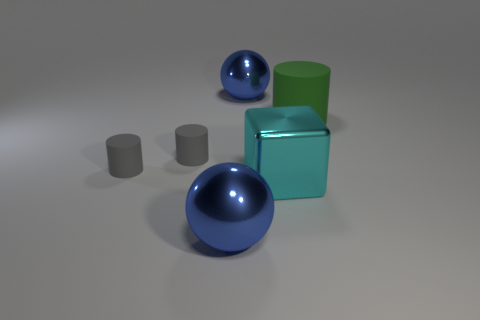Subtract all gray blocks. How many gray cylinders are left? 2 Subtract all tiny rubber cylinders. How many cylinders are left? 1 Add 1 large brown rubber spheres. How many objects exist? 7 Subtract 1 cylinders. How many cylinders are left? 2 Subtract all spheres. How many objects are left? 4 Subtract all blue objects. Subtract all cyan shiny cubes. How many objects are left? 3 Add 3 cubes. How many cubes are left? 4 Add 2 big yellow metallic balls. How many big yellow metallic balls exist? 2 Subtract 0 brown cylinders. How many objects are left? 6 Subtract all yellow cylinders. Subtract all cyan cubes. How many cylinders are left? 3 